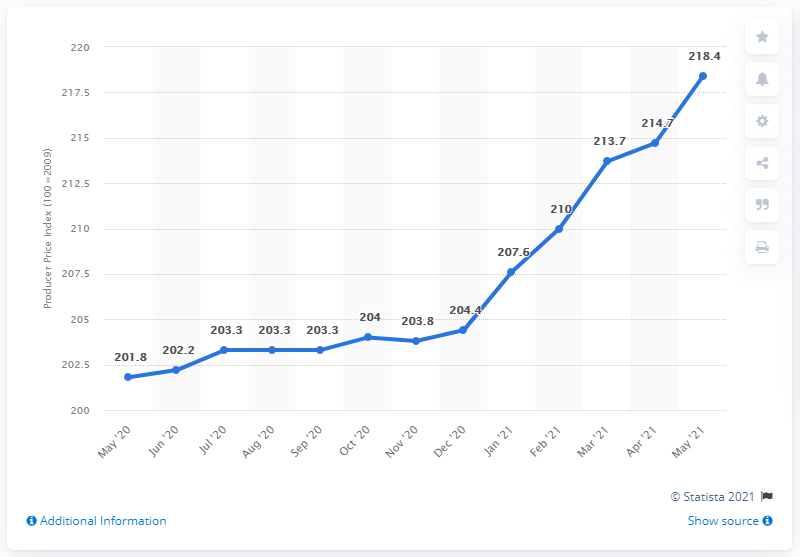Indicate a few pertinent items in this graphic. In May 2021, the PPI for finished goods in the United States was 218.4%. 